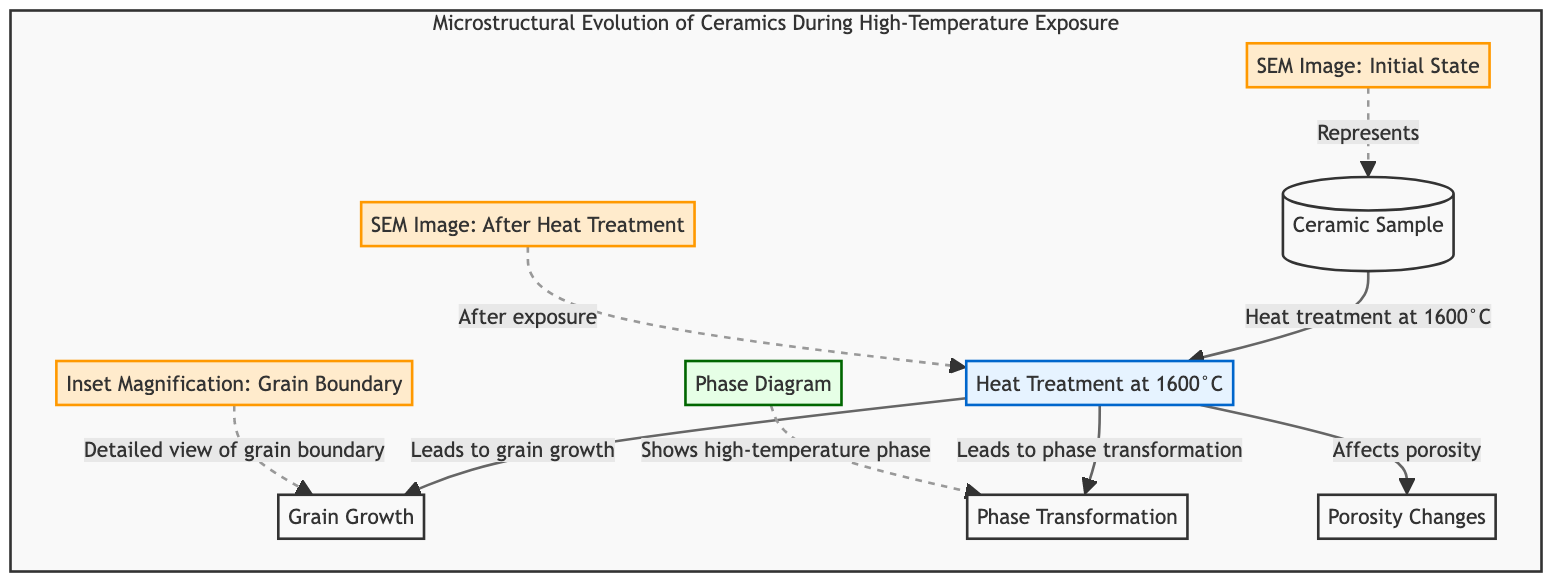What type of treatment is applied to the ceramic sample? The diagram shows that the ceramic sample undergoes "Heat Treatment at 1600°C" as its initial process, which is stated in node 2.
Answer: Heat Treatment at 1600°C How many processes are depicted in the diagram? By counting the nodes and identifying those that represent processes, we see four distinct processing steps: Heat Treatment, Grain Growth, Phase Transformation, and Porosity Changes.
Answer: 4 What is the consequence of heat treatment on grain structure? The diagram indicates that the heat treatment leads to "Grain Growth," as noted in the relationship between node 2 ("Heat Treatment at 1600°C") and node 3 ("Grain Growth").
Answer: Grain Growth Which graphical element represents the initial state of the ceramic sample? In the diagram, the "SEM Image: Initial State" is identified as node 6, which describes the state before heat treatment.
Answer: SEM Image: Initial State What does the inset magnification detail in the diagram? Node 9 states that the "Inset Magnification: Grain Boundary" provides a detailed view of the grain boundary, indicating its specific focus.
Answer: Grain Boundary What is the primary high-temperature phase shown in the phase diagram? Node 8 indicates that the "Phase Diagram" presents the high-temperature phase correlated with the phase transformation resulting from heat treatment.
Answer: High-Temperature Phase How does heat treatment affect porosity in the ceramic sample? According to the diagram, the heat treatment impacts porosity as stated in the relationship between node 2 and node 5, which indicates that changes in porosity occur as a result of heat treatment.
Answer: Affects Porosity What is illustrated in the SEM image after heat treatment? Node 7 is labeled "SEM Image: After Heat Treatment," suggesting it visually represents the state of the ceramic after undergoing the heat treatment process.
Answer: SEM Image: After Heat Treatment What concept does the phase transformation relate to in the context of high-temperature exposure? The diagram connects the "Phase Transformation" (node 4) directly to the "Heat Treatment at 1600°C" (node 2), signifying that this transformation occurs as a direct result of high-temperature exposure.
Answer: Phase Transformation 